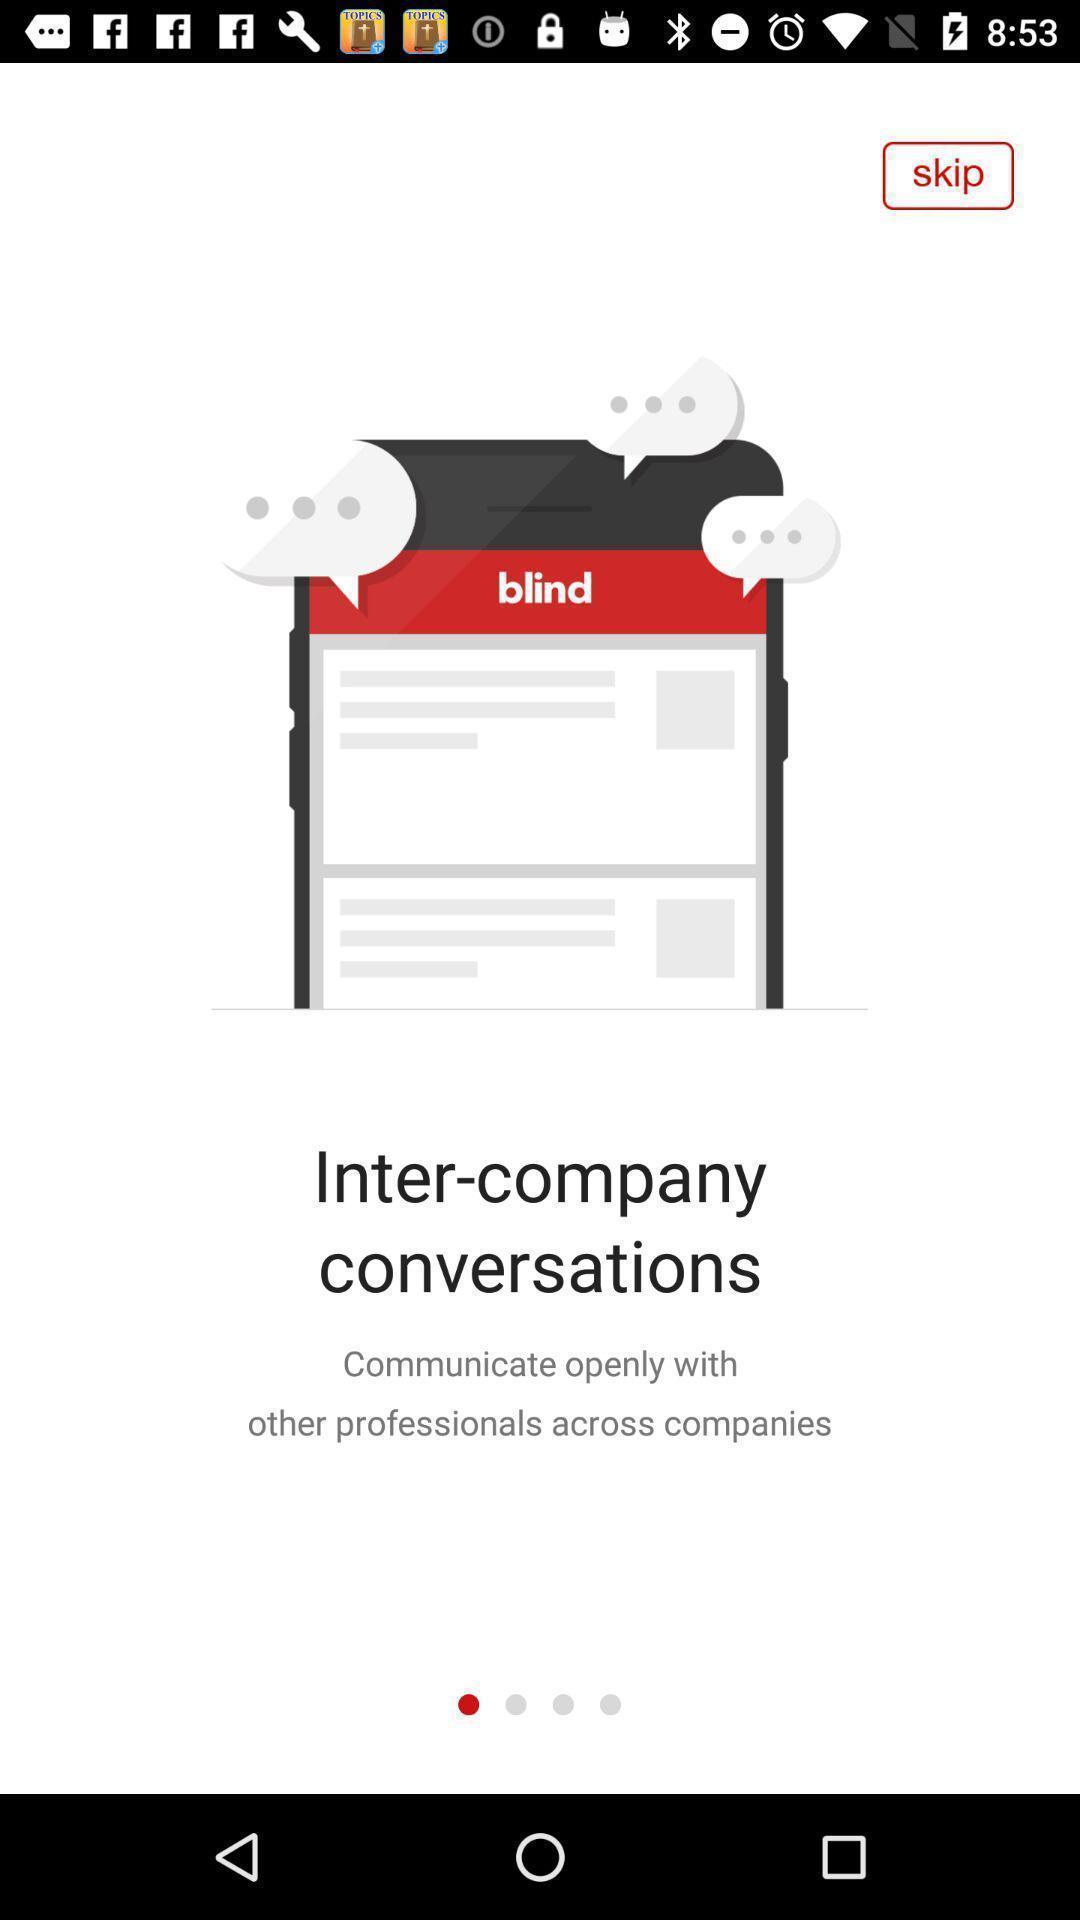Provide a description of this screenshot. Welcome page. 